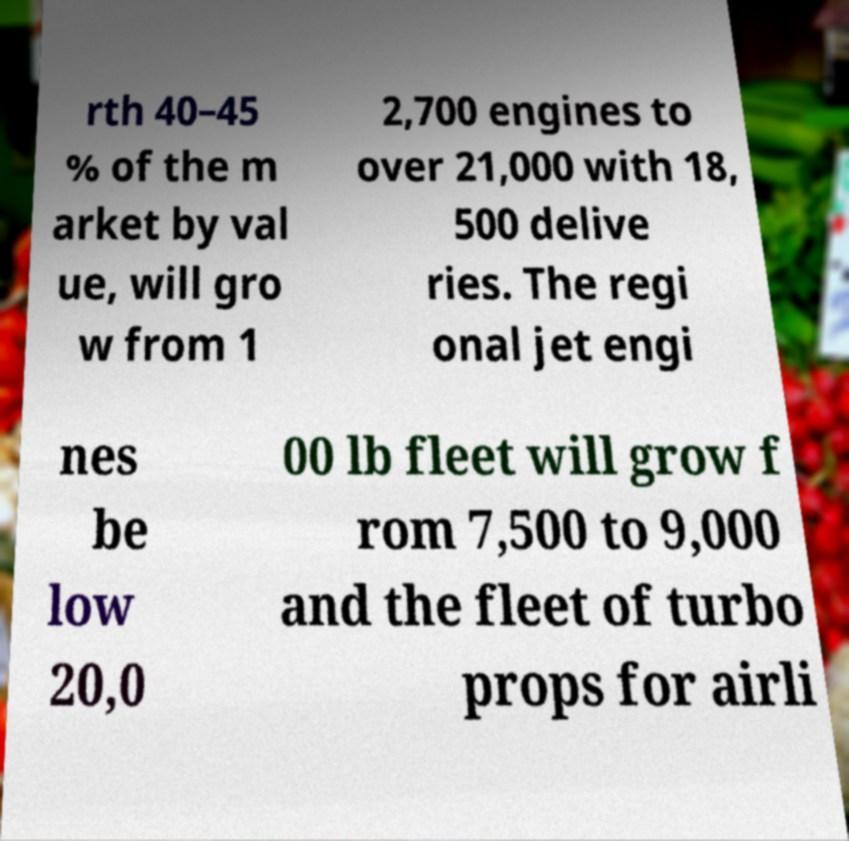Please read and relay the text visible in this image. What does it say? rth 40–45 % of the m arket by val ue, will gro w from 1 2,700 engines to over 21,000 with 18, 500 delive ries. The regi onal jet engi nes be low 20,0 00 lb fleet will grow f rom 7,500 to 9,000 and the fleet of turbo props for airli 